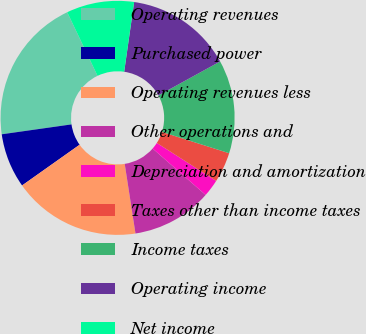<chart> <loc_0><loc_0><loc_500><loc_500><pie_chart><fcel>Operating revenues<fcel>Purchased power<fcel>Operating revenues less<fcel>Other operations and<fcel>Depreciation and amortization<fcel>Taxes other than income taxes<fcel>Income taxes<fcel>Operating income<fcel>Net income<nl><fcel>20.16%<fcel>7.56%<fcel>17.64%<fcel>11.11%<fcel>2.39%<fcel>4.17%<fcel>12.89%<fcel>14.74%<fcel>9.34%<nl></chart> 